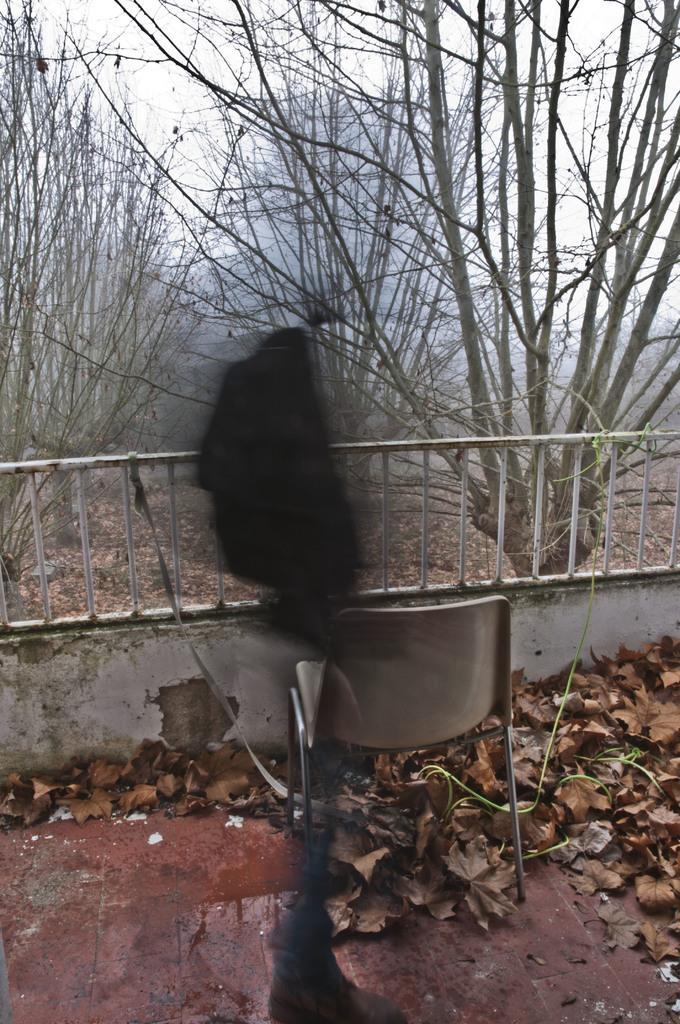How would you summarize this image in a sentence or two? In this picture we can see a chair and some leaves at the bottom, there is railing in the middle, in the background there are some trees, we can see the sky at the top of the picture. 